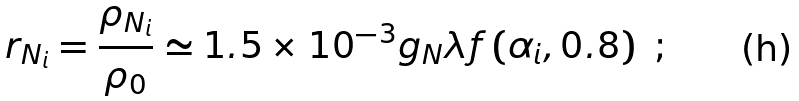Convert formula to latex. <formula><loc_0><loc_0><loc_500><loc_500>r _ { N _ { i } } = \frac { \rho _ { N _ { i } } } { \rho _ { 0 } } \simeq 1 . 5 \times 1 0 ^ { - 3 } g _ { N } \lambda f \left ( \alpha _ { i } , 0 . 8 \right ) \ ;</formula> 